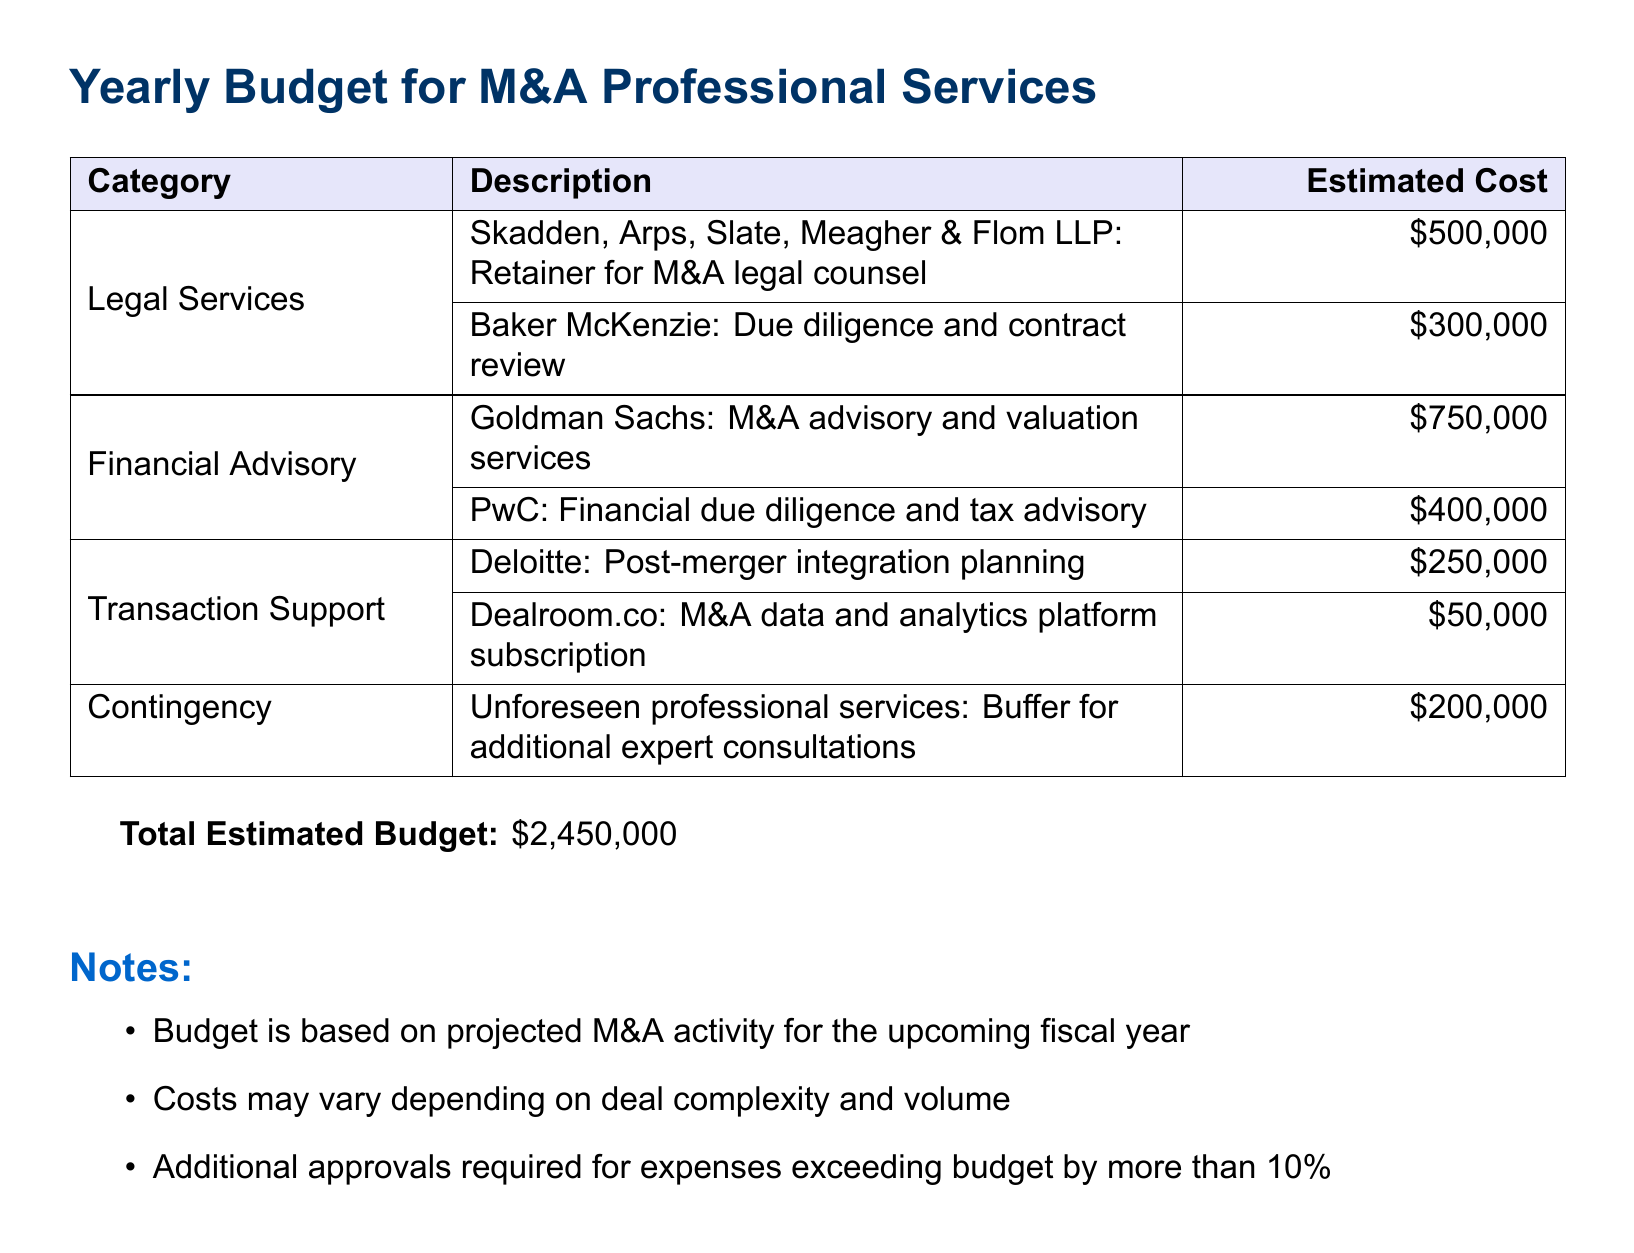what is the total estimated budget? The total estimated budget is clearly stated at the bottom of the document as the cumulative amount of all categories.
Answer: $2,450,000 who is the legal counsel provided by Skadden, Arps, Slate, Meagher & Flom LLP? This information can be found under the legal services category describing the retainer for M&A legal counsel.
Answer: M&A legal counsel how much is allocated for Goldman Sachs' advisory services? The document specifies the cost associated with Goldman Sachs in the financial advisory section.
Answer: $750,000 what is the purpose of the contingency budget? The purpose of the contingency budget is mentioned in the notes section to account for unforeseen circumstances.
Answer: Buffer for additional expert consultations which firm provides the post-merger integration planning? This can be found in the transaction support category detailing the role of Deloitte.
Answer: Deloitte how much is budgeted for legal services overall? Overall legal services costs can be calculated by adding individual legal service estimates.
Answer: $800,000 what is the estimated cost for the M&A data and analytics platform subscription? This figure is specifically outlined under transaction support in the budget.
Answer: $50,000 what might affect the costs mentioned in the budget? The notes section provides clarity on factors affecting costs, especially deal complexity and volume.
Answer: Deal complexity and volume 